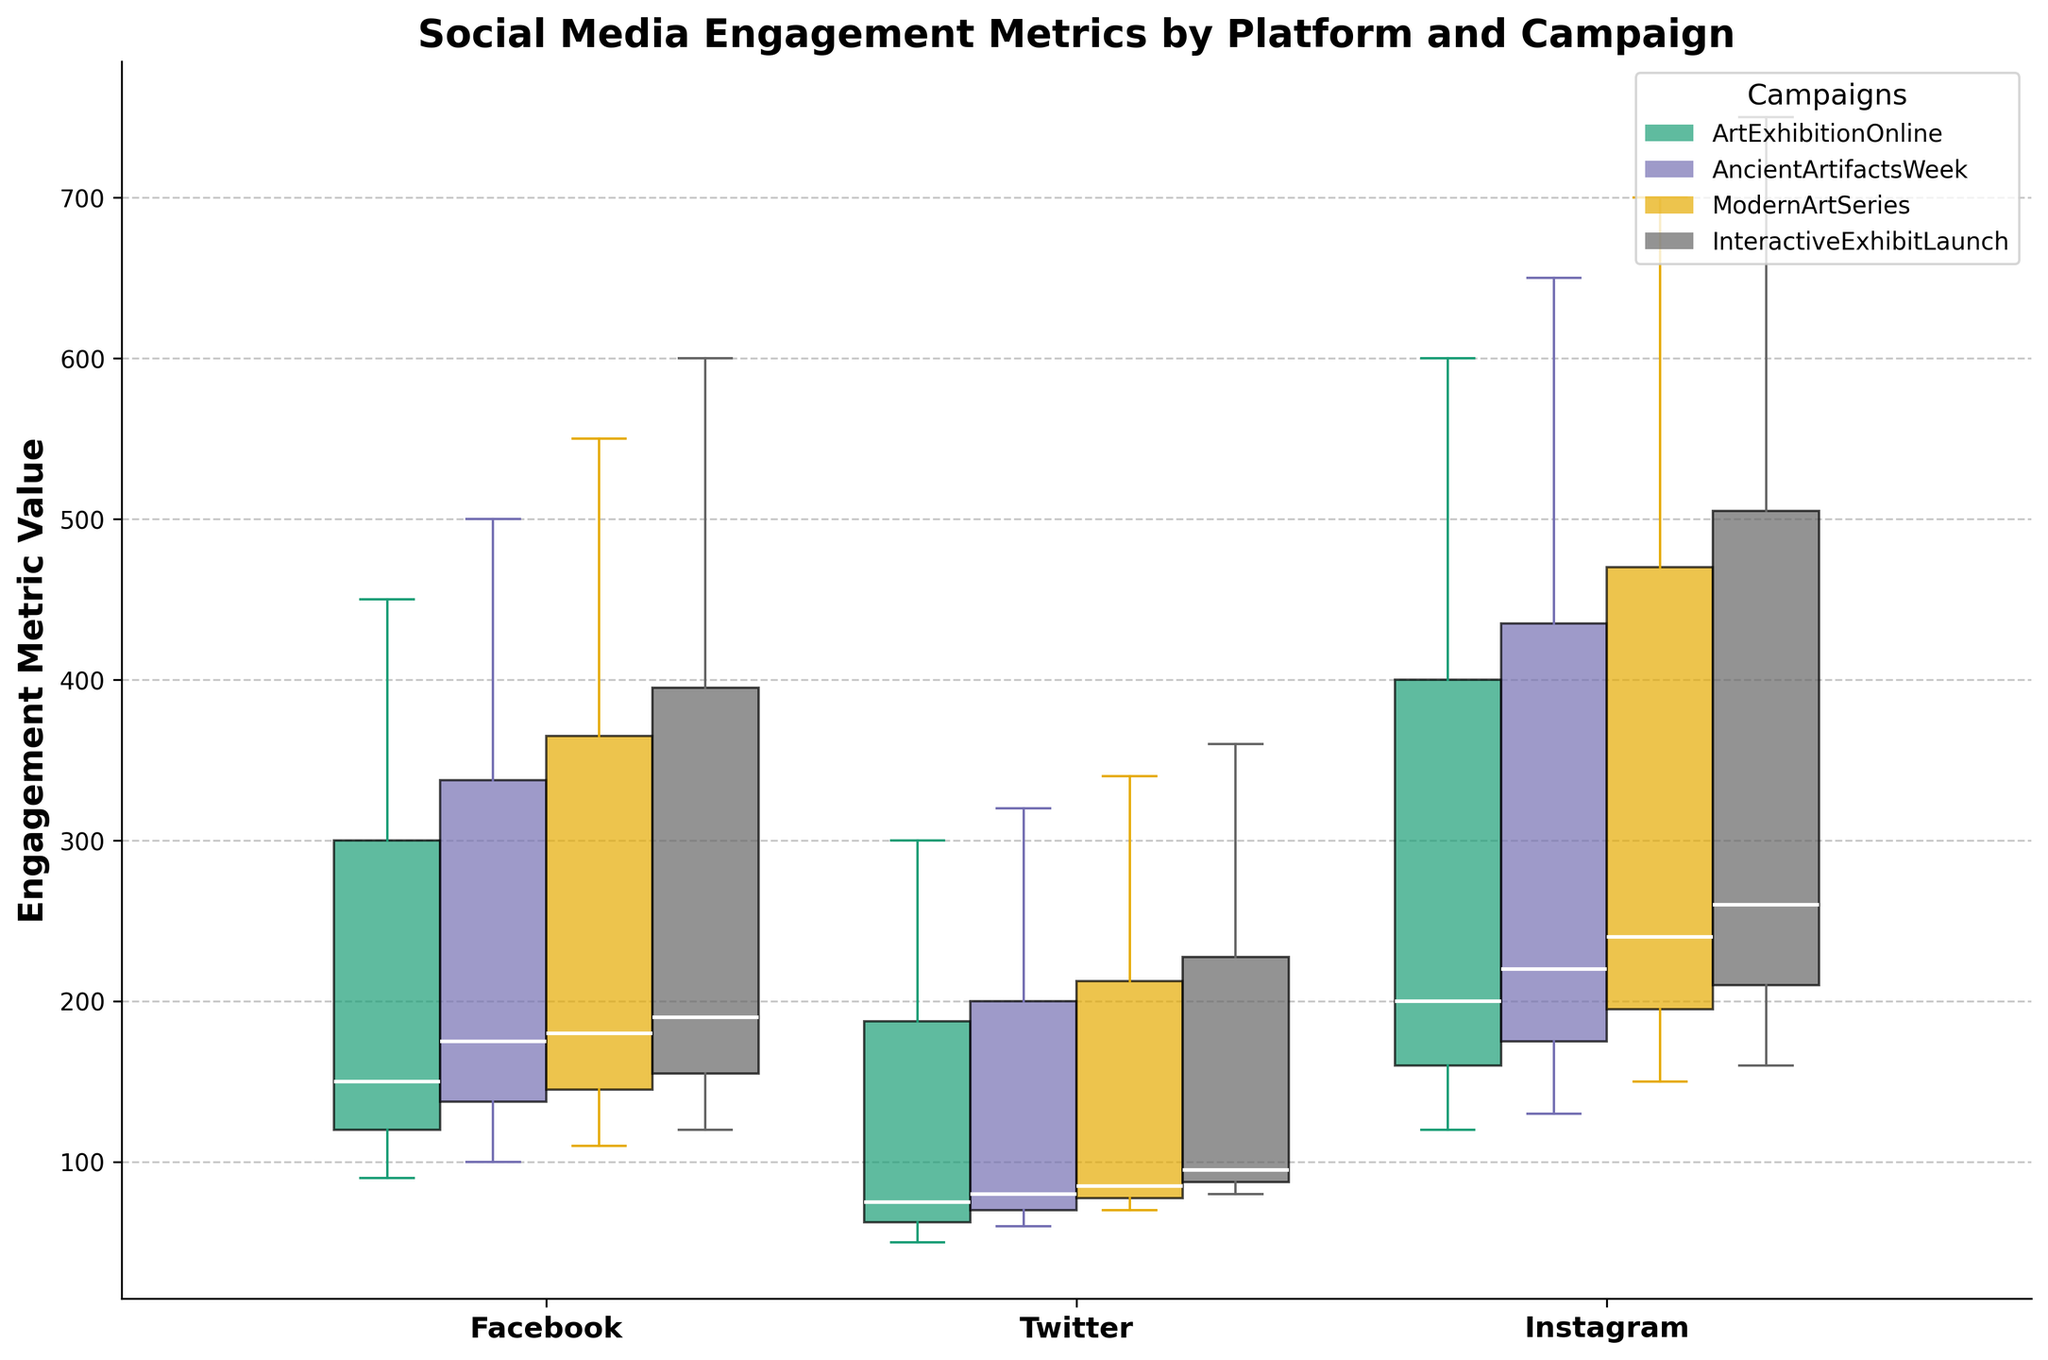What is the title of the figure? The title is usually found at the top of the figure, in this case, it is "Social Media Engagement Metrics by Platform and Campaign."
Answer: Social Media Engagement Metrics by Platform and Campaign What are the platforms compared in the figure? The platforms are identified by the x-axis labels, which include "Facebook," "Twitter," and "Instagram."
Answer: Facebook, Twitter, Instagram Which campaign has the highest engagement metric value on Instagram? By looking at the maximum value of the boxes plotted for Instagram, the "InteractiveExhibitLaunch" campaign has the highest value touching around 750.
Answer: InteractiveExhibitLaunch What is the range for 'Like' engagement metric on Facebook for the ArtExhibitionOnline campaign? For the 'Like' metric under the ArtExhibitionOnline campaign on Facebook, the lowest value is at 450 and the highest is around 600, the difference is 150.
Answer: 150 How do the median 'Like' values on Instagram compare across campaigns? Comparing the line within the boxes for "Like" on Instagram, the median values for "ArtExhibitionOnline," "AncientArtifactsWeek," "ModernArtSeries," and "InteractiveExhibitLaunch" gradually increase from around 600 to 750.
Answer: Increasing from 600 to 750 Which campaign has the most engaged users on Twitter? Examining the boxes' heights for Twitter across all campaigns, "InteractiveExhibitLaunch" shows the highest values, indicating it has the highest user engagement.
Answer: InteractiveExhibitLaunch What is the interquartile range (IQR) for 'Comment' on Instagram during the AncientArtifactsWeek campaign? The IQR is the distance between the first and third quartiles in the boxplot. For 'Comment' on Instagram during the AncientArtifactsWeek campaign, the lower quartile is around 200 and the upper quartile is around 220, making the IQR 20.
Answer: 20 Which platform shows the widest distribution of 'Like' values for the ModernArtSeries campaign? The width of the box indicates the distribution of the data. For 'Like' values during the ModernArtSeries campaign, Facebook shows the widest distribution.
Answer: Facebook Are there any outliers in the engagement metrics for the InteractiveExhibitLaunch campaign? Outliers are indicated by dots outside the whiskers of a boxplot. For the InteractiveExhibitLaunch campaign, there are no dots shown outside any of the whiskers, indicating no outliers.
Answer: No How does the spread of 'Share' values on Instagram compare across different campaigns? By comparing the widths of the boxes for 'Share' on Instagram, the spread is widest in the "InteractiveExhibitLaunch" campaign, indicating more variation compared to other campaigns.
Answer: Widest in InteractiveExhibitLaunch 